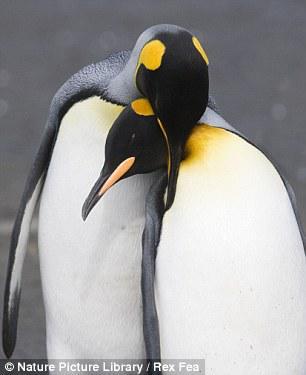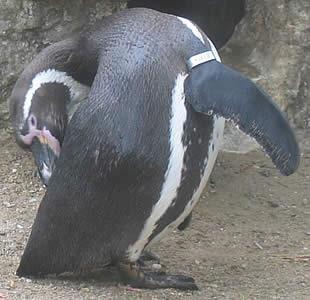The first image is the image on the left, the second image is the image on the right. Considering the images on both sides, is "There is a total of 1 penguin grooming themselves." valid? Answer yes or no. Yes. The first image is the image on the left, the second image is the image on the right. For the images displayed, is the sentence "Each of the images in the pair show exactly two penguins." factually correct? Answer yes or no. No. 